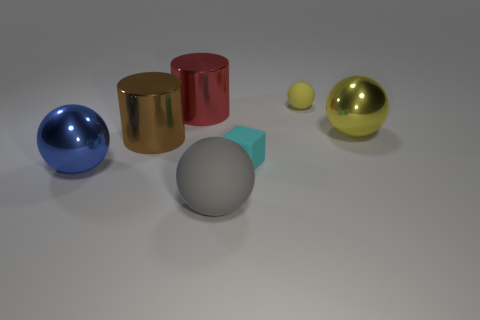Add 2 small green rubber cylinders. How many objects exist? 9 Subtract all cylinders. How many objects are left? 5 Add 2 tiny cyan rubber cubes. How many tiny cyan rubber cubes are left? 3 Add 4 large red things. How many large red things exist? 5 Subtract 0 brown blocks. How many objects are left? 7 Subtract all red cylinders. Subtract all large gray objects. How many objects are left? 5 